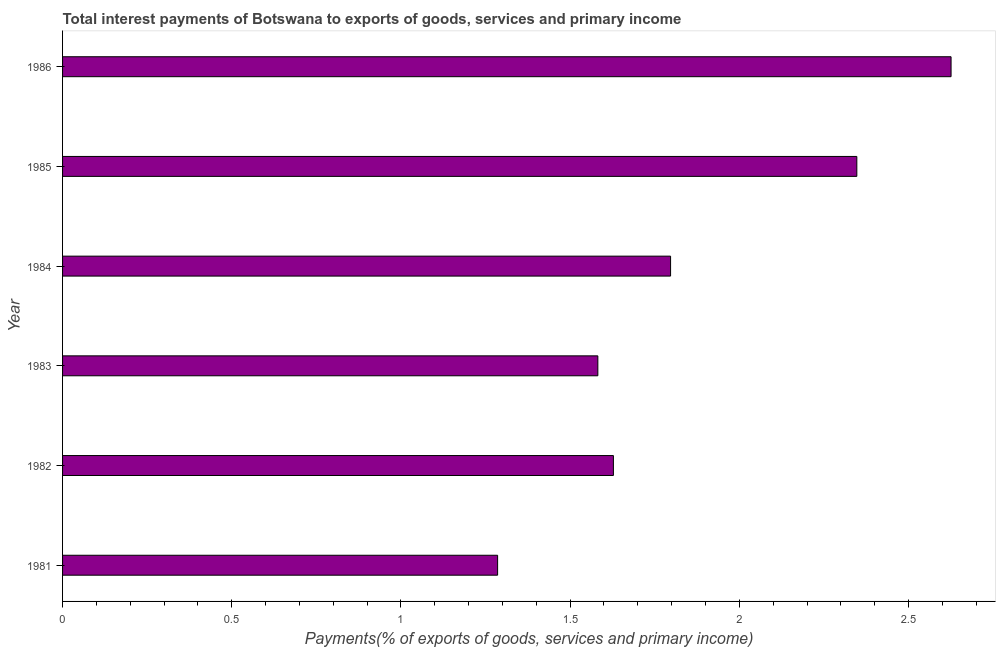Does the graph contain any zero values?
Provide a succinct answer. No. Does the graph contain grids?
Your response must be concise. No. What is the title of the graph?
Your answer should be compact. Total interest payments of Botswana to exports of goods, services and primary income. What is the label or title of the X-axis?
Make the answer very short. Payments(% of exports of goods, services and primary income). What is the label or title of the Y-axis?
Your answer should be very brief. Year. What is the total interest payments on external debt in 1986?
Offer a very short reply. 2.63. Across all years, what is the maximum total interest payments on external debt?
Make the answer very short. 2.63. Across all years, what is the minimum total interest payments on external debt?
Your answer should be compact. 1.29. In which year was the total interest payments on external debt minimum?
Offer a very short reply. 1981. What is the sum of the total interest payments on external debt?
Offer a terse response. 11.27. What is the difference between the total interest payments on external debt in 1985 and 1986?
Your answer should be very brief. -0.28. What is the average total interest payments on external debt per year?
Give a very brief answer. 1.88. What is the median total interest payments on external debt?
Offer a very short reply. 1.71. In how many years, is the total interest payments on external debt greater than 0.5 %?
Make the answer very short. 6. What is the ratio of the total interest payments on external debt in 1984 to that in 1986?
Offer a terse response. 0.68. Is the total interest payments on external debt in 1982 less than that in 1983?
Give a very brief answer. No. What is the difference between the highest and the second highest total interest payments on external debt?
Ensure brevity in your answer.  0.28. What is the difference between the highest and the lowest total interest payments on external debt?
Offer a terse response. 1.34. In how many years, is the total interest payments on external debt greater than the average total interest payments on external debt taken over all years?
Ensure brevity in your answer.  2. How many bars are there?
Your answer should be very brief. 6. Are all the bars in the graph horizontal?
Provide a succinct answer. Yes. What is the Payments(% of exports of goods, services and primary income) of 1981?
Provide a succinct answer. 1.29. What is the Payments(% of exports of goods, services and primary income) in 1982?
Provide a succinct answer. 1.63. What is the Payments(% of exports of goods, services and primary income) of 1983?
Give a very brief answer. 1.58. What is the Payments(% of exports of goods, services and primary income) of 1984?
Your answer should be compact. 1.8. What is the Payments(% of exports of goods, services and primary income) of 1985?
Offer a very short reply. 2.35. What is the Payments(% of exports of goods, services and primary income) in 1986?
Provide a succinct answer. 2.63. What is the difference between the Payments(% of exports of goods, services and primary income) in 1981 and 1982?
Your response must be concise. -0.34. What is the difference between the Payments(% of exports of goods, services and primary income) in 1981 and 1983?
Keep it short and to the point. -0.3. What is the difference between the Payments(% of exports of goods, services and primary income) in 1981 and 1984?
Make the answer very short. -0.51. What is the difference between the Payments(% of exports of goods, services and primary income) in 1981 and 1985?
Offer a terse response. -1.06. What is the difference between the Payments(% of exports of goods, services and primary income) in 1981 and 1986?
Provide a short and direct response. -1.34. What is the difference between the Payments(% of exports of goods, services and primary income) in 1982 and 1983?
Ensure brevity in your answer.  0.05. What is the difference between the Payments(% of exports of goods, services and primary income) in 1982 and 1984?
Your answer should be compact. -0.17. What is the difference between the Payments(% of exports of goods, services and primary income) in 1982 and 1985?
Provide a short and direct response. -0.72. What is the difference between the Payments(% of exports of goods, services and primary income) in 1982 and 1986?
Ensure brevity in your answer.  -1. What is the difference between the Payments(% of exports of goods, services and primary income) in 1983 and 1984?
Keep it short and to the point. -0.21. What is the difference between the Payments(% of exports of goods, services and primary income) in 1983 and 1985?
Provide a succinct answer. -0.77. What is the difference between the Payments(% of exports of goods, services and primary income) in 1983 and 1986?
Provide a short and direct response. -1.04. What is the difference between the Payments(% of exports of goods, services and primary income) in 1984 and 1985?
Provide a succinct answer. -0.55. What is the difference between the Payments(% of exports of goods, services and primary income) in 1984 and 1986?
Offer a very short reply. -0.83. What is the difference between the Payments(% of exports of goods, services and primary income) in 1985 and 1986?
Your answer should be very brief. -0.28. What is the ratio of the Payments(% of exports of goods, services and primary income) in 1981 to that in 1982?
Give a very brief answer. 0.79. What is the ratio of the Payments(% of exports of goods, services and primary income) in 1981 to that in 1983?
Make the answer very short. 0.81. What is the ratio of the Payments(% of exports of goods, services and primary income) in 1981 to that in 1984?
Provide a succinct answer. 0.72. What is the ratio of the Payments(% of exports of goods, services and primary income) in 1981 to that in 1985?
Your answer should be compact. 0.55. What is the ratio of the Payments(% of exports of goods, services and primary income) in 1981 to that in 1986?
Ensure brevity in your answer.  0.49. What is the ratio of the Payments(% of exports of goods, services and primary income) in 1982 to that in 1983?
Ensure brevity in your answer.  1.03. What is the ratio of the Payments(% of exports of goods, services and primary income) in 1982 to that in 1984?
Give a very brief answer. 0.91. What is the ratio of the Payments(% of exports of goods, services and primary income) in 1982 to that in 1985?
Make the answer very short. 0.69. What is the ratio of the Payments(% of exports of goods, services and primary income) in 1982 to that in 1986?
Ensure brevity in your answer.  0.62. What is the ratio of the Payments(% of exports of goods, services and primary income) in 1983 to that in 1984?
Provide a succinct answer. 0.88. What is the ratio of the Payments(% of exports of goods, services and primary income) in 1983 to that in 1985?
Give a very brief answer. 0.67. What is the ratio of the Payments(% of exports of goods, services and primary income) in 1983 to that in 1986?
Offer a terse response. 0.6. What is the ratio of the Payments(% of exports of goods, services and primary income) in 1984 to that in 1985?
Provide a succinct answer. 0.77. What is the ratio of the Payments(% of exports of goods, services and primary income) in 1984 to that in 1986?
Ensure brevity in your answer.  0.68. What is the ratio of the Payments(% of exports of goods, services and primary income) in 1985 to that in 1986?
Make the answer very short. 0.89. 